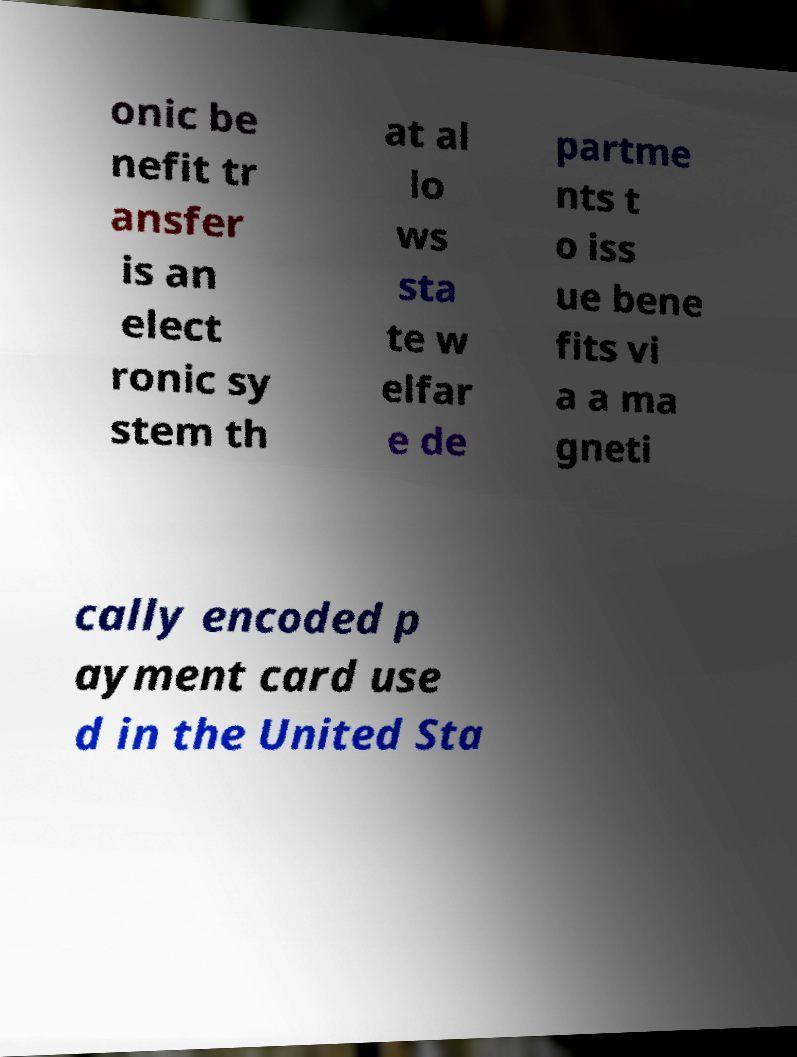Could you extract and type out the text from this image? onic be nefit tr ansfer is an elect ronic sy stem th at al lo ws sta te w elfar e de partme nts t o iss ue bene fits vi a a ma gneti cally encoded p ayment card use d in the United Sta 